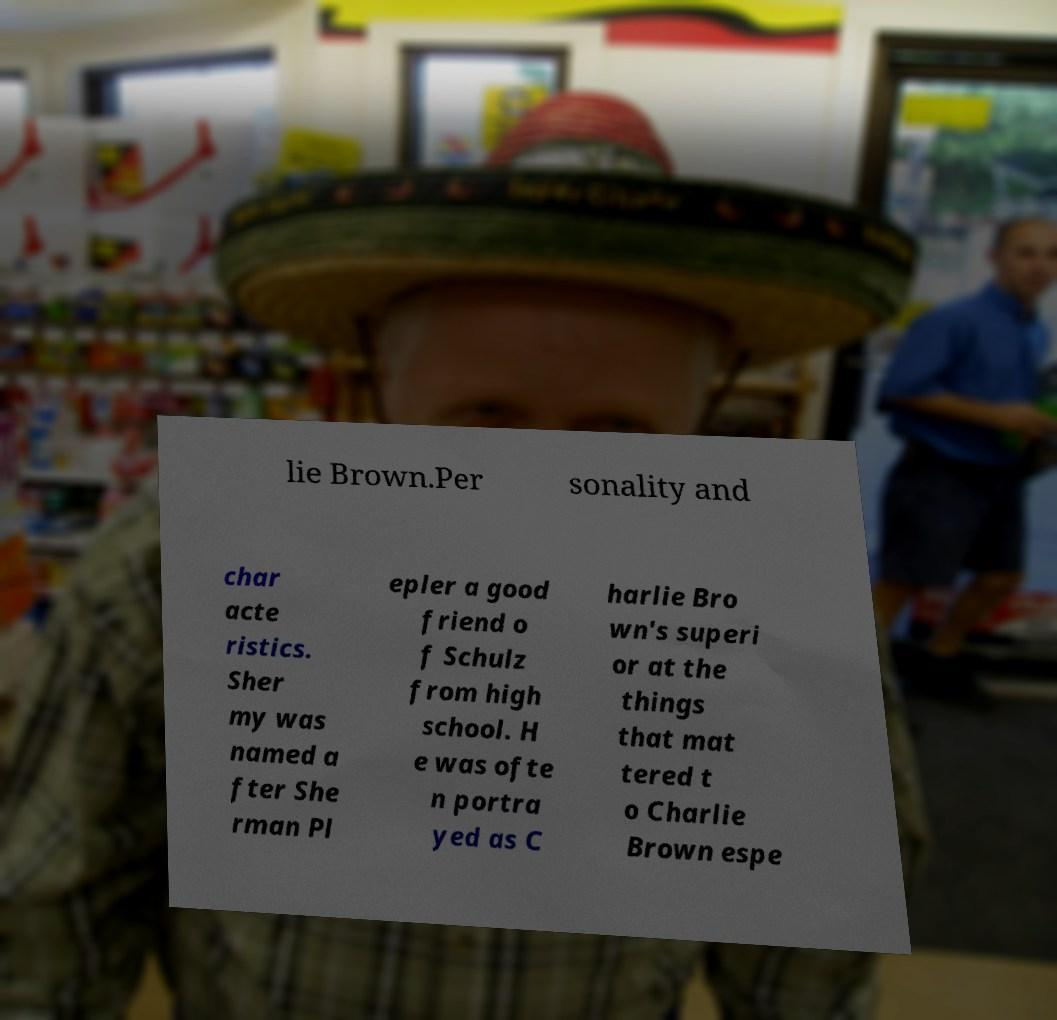Can you read and provide the text displayed in the image?This photo seems to have some interesting text. Can you extract and type it out for me? lie Brown.Per sonality and char acte ristics. Sher my was named a fter She rman Pl epler a good friend o f Schulz from high school. H e was ofte n portra yed as C harlie Bro wn's superi or at the things that mat tered t o Charlie Brown espe 